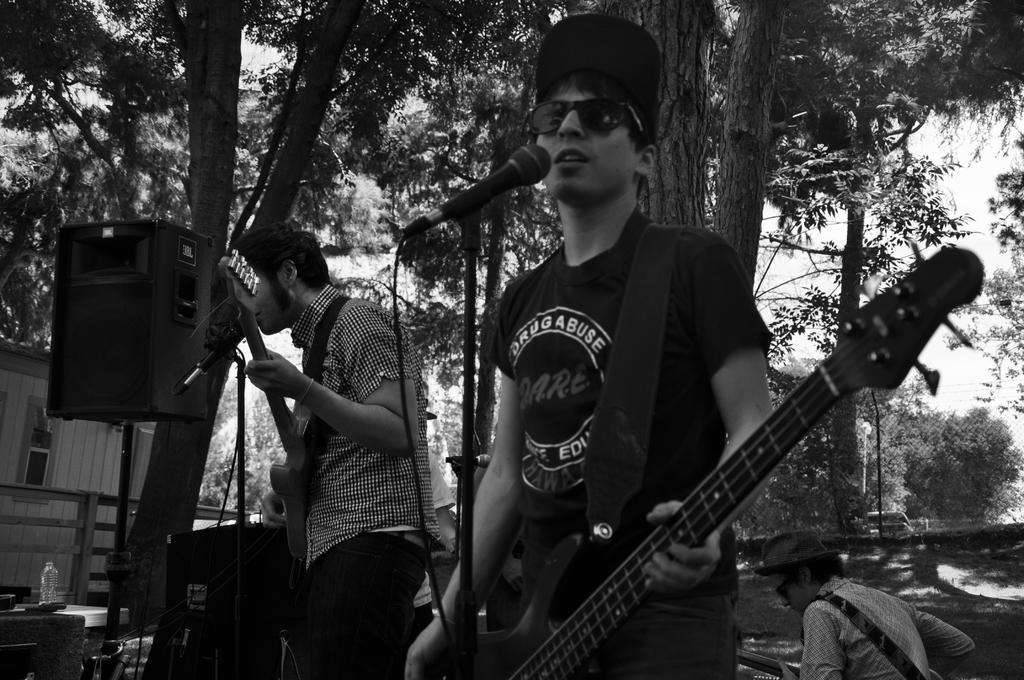Please provide a concise description of this image. This is the picture of two people playing guitars in front of the mics and around there are some trees, speaker and a person behind. 